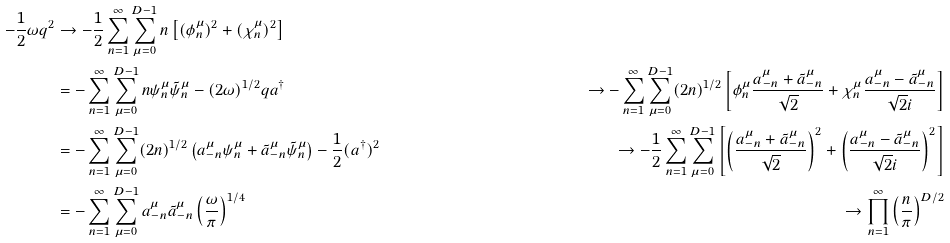Convert formula to latex. <formula><loc_0><loc_0><loc_500><loc_500>- \frac { 1 } { 2 } \omega q ^ { 2 } & \to - \frac { 1 } { 2 } \sum _ { n = 1 } ^ { \infty } \sum _ { \mu = 0 } ^ { D - 1 } n \left [ ( \phi _ { n } ^ { \mu } ) ^ { 2 } + ( \chi _ { n } ^ { \mu } ) ^ { 2 } \right ] \\ & = - \sum _ { n = 1 } ^ { \infty } \sum _ { \mu = 0 } ^ { D - 1 } n \psi _ { n } ^ { \mu } \tilde { \psi } _ { n } ^ { \mu } - ( 2 \omega ) ^ { 1 / 2 } q a ^ { \dagger } & \to - \sum _ { n = 1 } ^ { \infty } \sum _ { \mu = 0 } ^ { D - 1 } ( 2 n ) ^ { 1 / 2 } \left [ \phi _ { n } ^ { \mu } \frac { a _ { - n } ^ { \mu } + \tilde { a } _ { - n } ^ { \mu } } { \sqrt { 2 } } + \chi _ { n } ^ { \mu } \frac { a _ { - n } ^ { \mu } - \tilde { a } _ { - n } ^ { \mu } } { \sqrt { 2 } i } \right ] \\ & = - \sum _ { n = 1 } ^ { \infty } \sum _ { \mu = 0 } ^ { D - 1 } ( 2 n ) ^ { 1 / 2 } \left ( a _ { - n } ^ { \mu } \psi _ { n } ^ { \mu } + \tilde { a } _ { - n } ^ { \mu } \tilde { \psi } _ { n } ^ { \mu } \right ) - \frac { 1 } { 2 } ( a ^ { \dagger } ) ^ { 2 } & \to - \frac { 1 } { 2 } \sum _ { n = 1 } ^ { \infty } \sum _ { \mu = 0 } ^ { D - 1 } \left [ \left ( \frac { a _ { - n } ^ { \mu } + \tilde { a } _ { - n } ^ { \mu } } { \sqrt { 2 } } \right ) ^ { 2 } + \left ( \frac { a _ { - n } ^ { \mu } - \tilde { a } _ { - n } ^ { \mu } } { \sqrt { 2 } i } \right ) ^ { 2 } \right ] \\ & = - \sum _ { n = 1 } ^ { \infty } \sum _ { \mu = 0 } ^ { D - 1 } a _ { - n } ^ { \mu } \tilde { a } _ { - n } ^ { \mu } \left ( \frac { \omega } { \pi } \right ) ^ { 1 / 4 } & \to \prod _ { n = 1 } ^ { \infty } \left ( \frac { n } { \pi } \right ) ^ { D / 2 }</formula> 